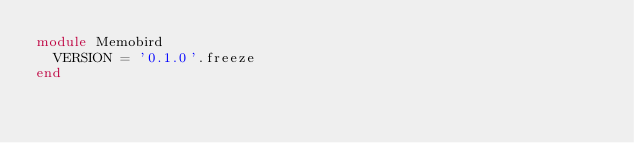Convert code to text. <code><loc_0><loc_0><loc_500><loc_500><_Ruby_>module Memobird
  VERSION = '0.1.0'.freeze
end
</code> 